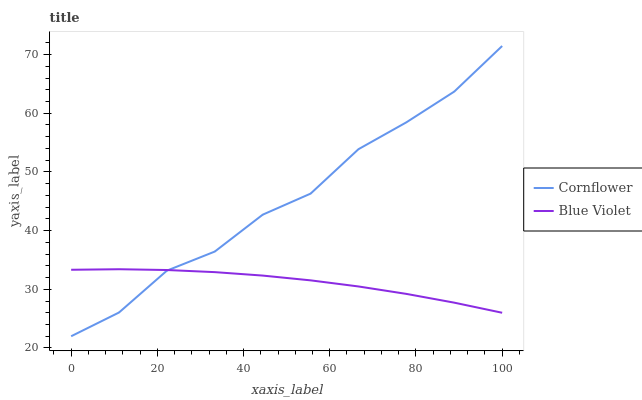Does Blue Violet have the minimum area under the curve?
Answer yes or no. Yes. Does Cornflower have the maximum area under the curve?
Answer yes or no. Yes. Does Blue Violet have the maximum area under the curve?
Answer yes or no. No. Is Blue Violet the smoothest?
Answer yes or no. Yes. Is Cornflower the roughest?
Answer yes or no. Yes. Is Blue Violet the roughest?
Answer yes or no. No. Does Cornflower have the lowest value?
Answer yes or no. Yes. Does Blue Violet have the lowest value?
Answer yes or no. No. Does Cornflower have the highest value?
Answer yes or no. Yes. Does Blue Violet have the highest value?
Answer yes or no. No. Does Blue Violet intersect Cornflower?
Answer yes or no. Yes. Is Blue Violet less than Cornflower?
Answer yes or no. No. Is Blue Violet greater than Cornflower?
Answer yes or no. No. 